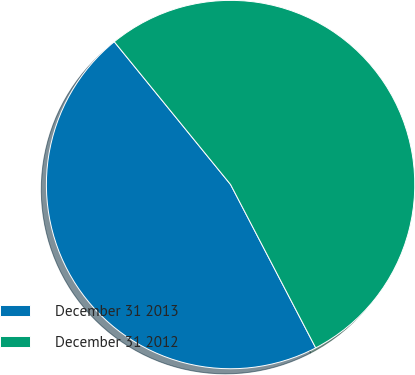<chart> <loc_0><loc_0><loc_500><loc_500><pie_chart><fcel>December 31 2013<fcel>December 31 2012<nl><fcel>46.77%<fcel>53.23%<nl></chart> 